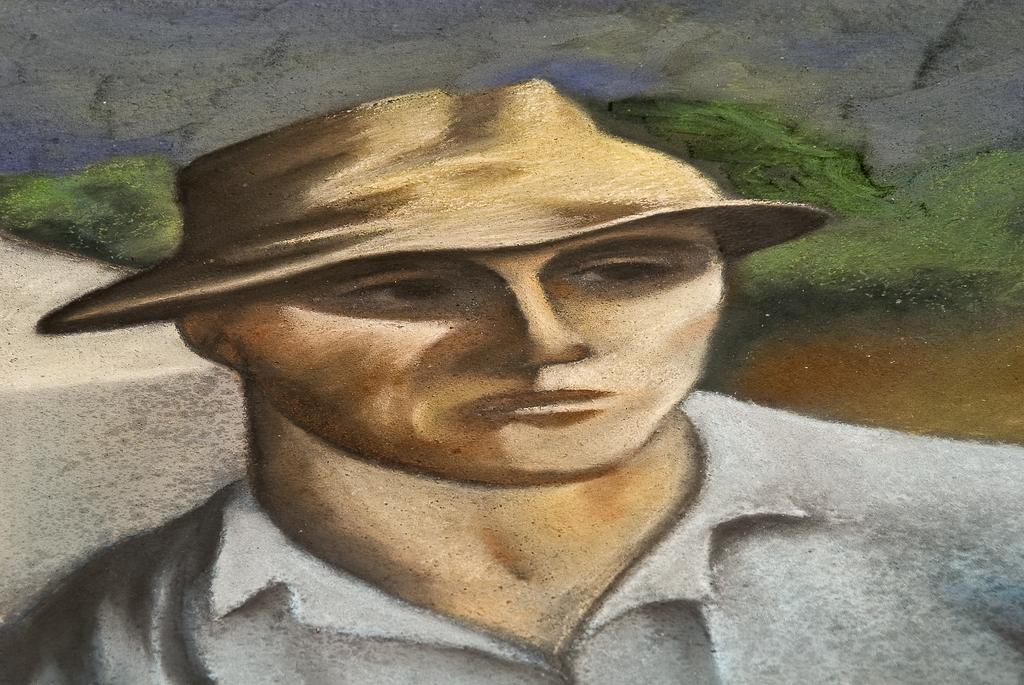What is depicted in the painting in the image? There is a painting of a person in the image. What can be seen in the background of the painting? There are trees and water visible in the background of the image. How many leaves are on the tank in the image? There is no tank present in the image, and therefore no leaves on a tank can be observed. 